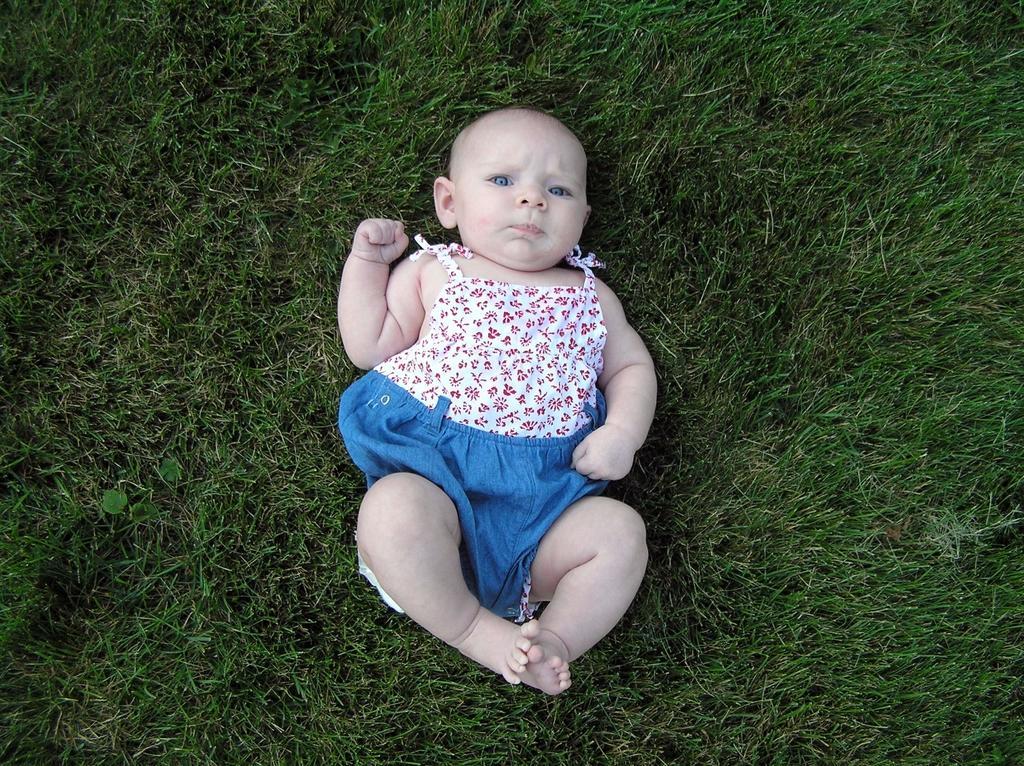Describe this image in one or two sentences. In this image I can see grass and here I can see a baby. I can see this baby is wearing white and blue colour dress. 